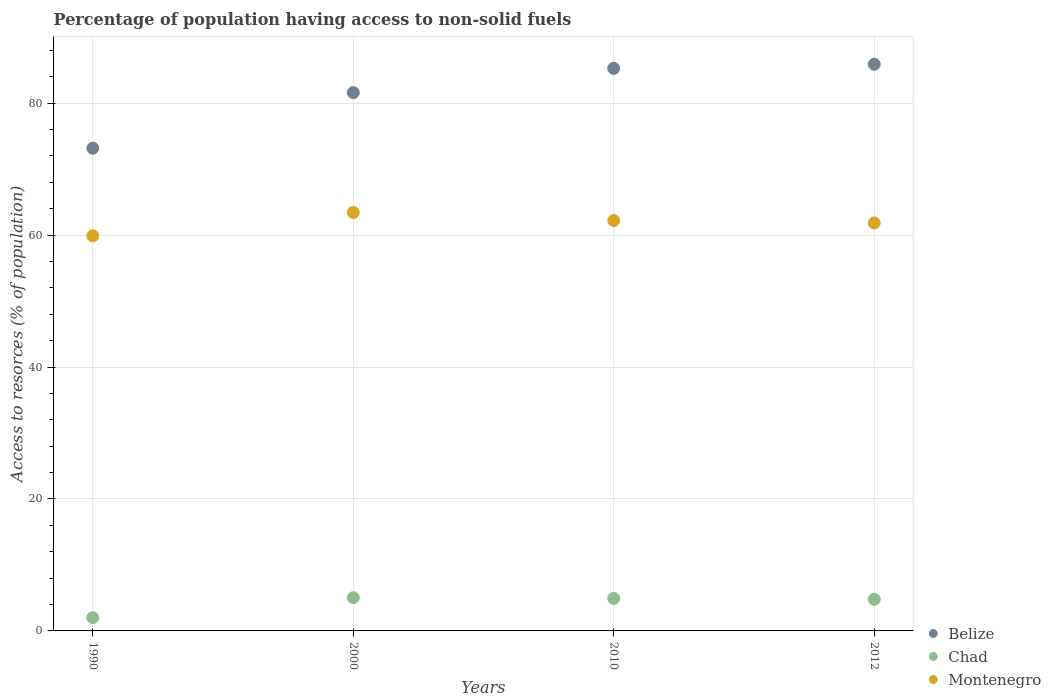How many different coloured dotlines are there?
Your response must be concise. 3. Is the number of dotlines equal to the number of legend labels?
Keep it short and to the point. Yes. What is the percentage of population having access to non-solid fuels in Chad in 2010?
Make the answer very short. 4.92. Across all years, what is the maximum percentage of population having access to non-solid fuels in Belize?
Provide a short and direct response. 85.89. Across all years, what is the minimum percentage of population having access to non-solid fuels in Chad?
Your response must be concise. 2.01. In which year was the percentage of population having access to non-solid fuels in Montenegro maximum?
Your answer should be compact. 2000. What is the total percentage of population having access to non-solid fuels in Chad in the graph?
Provide a short and direct response. 16.76. What is the difference between the percentage of population having access to non-solid fuels in Belize in 2000 and that in 2010?
Offer a very short reply. -3.67. What is the difference between the percentage of population having access to non-solid fuels in Belize in 2010 and the percentage of population having access to non-solid fuels in Montenegro in 2012?
Ensure brevity in your answer.  23.43. What is the average percentage of population having access to non-solid fuels in Montenegro per year?
Keep it short and to the point. 61.84. In the year 1990, what is the difference between the percentage of population having access to non-solid fuels in Chad and percentage of population having access to non-solid fuels in Montenegro?
Give a very brief answer. -57.87. What is the ratio of the percentage of population having access to non-solid fuels in Belize in 1990 to that in 2012?
Give a very brief answer. 0.85. Is the percentage of population having access to non-solid fuels in Belize in 2000 less than that in 2012?
Offer a very short reply. Yes. Is the difference between the percentage of population having access to non-solid fuels in Chad in 2000 and 2012 greater than the difference between the percentage of population having access to non-solid fuels in Montenegro in 2000 and 2012?
Keep it short and to the point. No. What is the difference between the highest and the second highest percentage of population having access to non-solid fuels in Chad?
Your answer should be compact. 0.11. What is the difference between the highest and the lowest percentage of population having access to non-solid fuels in Belize?
Keep it short and to the point. 12.73. In how many years, is the percentage of population having access to non-solid fuels in Chad greater than the average percentage of population having access to non-solid fuels in Chad taken over all years?
Your response must be concise. 3. Is the sum of the percentage of population having access to non-solid fuels in Montenegro in 1990 and 2000 greater than the maximum percentage of population having access to non-solid fuels in Chad across all years?
Your answer should be compact. Yes. Is the percentage of population having access to non-solid fuels in Montenegro strictly greater than the percentage of population having access to non-solid fuels in Belize over the years?
Provide a short and direct response. No. Is the percentage of population having access to non-solid fuels in Belize strictly less than the percentage of population having access to non-solid fuels in Montenegro over the years?
Offer a very short reply. No. What is the difference between two consecutive major ticks on the Y-axis?
Your response must be concise. 20. Does the graph contain grids?
Provide a short and direct response. Yes. Where does the legend appear in the graph?
Provide a succinct answer. Bottom right. How many legend labels are there?
Your answer should be very brief. 3. How are the legend labels stacked?
Offer a very short reply. Vertical. What is the title of the graph?
Give a very brief answer. Percentage of population having access to non-solid fuels. What is the label or title of the Y-axis?
Offer a very short reply. Access to resorces (% of population). What is the Access to resorces (% of population) of Belize in 1990?
Your answer should be very brief. 73.17. What is the Access to resorces (% of population) of Chad in 1990?
Your answer should be compact. 2.01. What is the Access to resorces (% of population) in Montenegro in 1990?
Provide a succinct answer. 59.88. What is the Access to resorces (% of population) of Belize in 2000?
Your answer should be compact. 81.6. What is the Access to resorces (% of population) in Chad in 2000?
Your answer should be very brief. 5.04. What is the Access to resorces (% of population) in Montenegro in 2000?
Keep it short and to the point. 63.42. What is the Access to resorces (% of population) of Belize in 2010?
Your answer should be very brief. 85.27. What is the Access to resorces (% of population) in Chad in 2010?
Make the answer very short. 4.92. What is the Access to resorces (% of population) in Montenegro in 2010?
Offer a very short reply. 62.2. What is the Access to resorces (% of population) of Belize in 2012?
Your answer should be compact. 85.89. What is the Access to resorces (% of population) of Chad in 2012?
Your response must be concise. 4.79. What is the Access to resorces (% of population) of Montenegro in 2012?
Your answer should be very brief. 61.85. Across all years, what is the maximum Access to resorces (% of population) in Belize?
Give a very brief answer. 85.89. Across all years, what is the maximum Access to resorces (% of population) in Chad?
Provide a short and direct response. 5.04. Across all years, what is the maximum Access to resorces (% of population) of Montenegro?
Provide a short and direct response. 63.42. Across all years, what is the minimum Access to resorces (% of population) in Belize?
Give a very brief answer. 73.17. Across all years, what is the minimum Access to resorces (% of population) of Chad?
Your answer should be very brief. 2.01. Across all years, what is the minimum Access to resorces (% of population) of Montenegro?
Give a very brief answer. 59.88. What is the total Access to resorces (% of population) in Belize in the graph?
Ensure brevity in your answer.  325.93. What is the total Access to resorces (% of population) of Chad in the graph?
Keep it short and to the point. 16.76. What is the total Access to resorces (% of population) of Montenegro in the graph?
Your answer should be compact. 247.34. What is the difference between the Access to resorces (% of population) of Belize in 1990 and that in 2000?
Provide a succinct answer. -8.43. What is the difference between the Access to resorces (% of population) of Chad in 1990 and that in 2000?
Your response must be concise. -3.03. What is the difference between the Access to resorces (% of population) in Montenegro in 1990 and that in 2000?
Ensure brevity in your answer.  -3.54. What is the difference between the Access to resorces (% of population) of Belize in 1990 and that in 2010?
Offer a very short reply. -12.1. What is the difference between the Access to resorces (% of population) of Chad in 1990 and that in 2010?
Provide a short and direct response. -2.92. What is the difference between the Access to resorces (% of population) of Montenegro in 1990 and that in 2010?
Ensure brevity in your answer.  -2.32. What is the difference between the Access to resorces (% of population) of Belize in 1990 and that in 2012?
Keep it short and to the point. -12.73. What is the difference between the Access to resorces (% of population) in Chad in 1990 and that in 2012?
Make the answer very short. -2.78. What is the difference between the Access to resorces (% of population) in Montenegro in 1990 and that in 2012?
Offer a very short reply. -1.97. What is the difference between the Access to resorces (% of population) in Belize in 2000 and that in 2010?
Your answer should be compact. -3.67. What is the difference between the Access to resorces (% of population) in Chad in 2000 and that in 2010?
Keep it short and to the point. 0.11. What is the difference between the Access to resorces (% of population) of Montenegro in 2000 and that in 2010?
Your response must be concise. 1.22. What is the difference between the Access to resorces (% of population) in Belize in 2000 and that in 2012?
Give a very brief answer. -4.3. What is the difference between the Access to resorces (% of population) of Chad in 2000 and that in 2012?
Your answer should be compact. 0.24. What is the difference between the Access to resorces (% of population) of Montenegro in 2000 and that in 2012?
Offer a very short reply. 1.58. What is the difference between the Access to resorces (% of population) of Belize in 2010 and that in 2012?
Keep it short and to the point. -0.62. What is the difference between the Access to resorces (% of population) of Chad in 2010 and that in 2012?
Keep it short and to the point. 0.13. What is the difference between the Access to resorces (% of population) of Montenegro in 2010 and that in 2012?
Keep it short and to the point. 0.35. What is the difference between the Access to resorces (% of population) in Belize in 1990 and the Access to resorces (% of population) in Chad in 2000?
Your answer should be compact. 68.13. What is the difference between the Access to resorces (% of population) in Belize in 1990 and the Access to resorces (% of population) in Montenegro in 2000?
Offer a terse response. 9.74. What is the difference between the Access to resorces (% of population) of Chad in 1990 and the Access to resorces (% of population) of Montenegro in 2000?
Give a very brief answer. -61.41. What is the difference between the Access to resorces (% of population) in Belize in 1990 and the Access to resorces (% of population) in Chad in 2010?
Offer a very short reply. 68.24. What is the difference between the Access to resorces (% of population) in Belize in 1990 and the Access to resorces (% of population) in Montenegro in 2010?
Keep it short and to the point. 10.97. What is the difference between the Access to resorces (% of population) of Chad in 1990 and the Access to resorces (% of population) of Montenegro in 2010?
Your response must be concise. -60.19. What is the difference between the Access to resorces (% of population) in Belize in 1990 and the Access to resorces (% of population) in Chad in 2012?
Provide a succinct answer. 68.38. What is the difference between the Access to resorces (% of population) in Belize in 1990 and the Access to resorces (% of population) in Montenegro in 2012?
Provide a short and direct response. 11.32. What is the difference between the Access to resorces (% of population) of Chad in 1990 and the Access to resorces (% of population) of Montenegro in 2012?
Offer a very short reply. -59.84. What is the difference between the Access to resorces (% of population) in Belize in 2000 and the Access to resorces (% of population) in Chad in 2010?
Your answer should be compact. 76.67. What is the difference between the Access to resorces (% of population) in Belize in 2000 and the Access to resorces (% of population) in Montenegro in 2010?
Give a very brief answer. 19.4. What is the difference between the Access to resorces (% of population) in Chad in 2000 and the Access to resorces (% of population) in Montenegro in 2010?
Ensure brevity in your answer.  -57.16. What is the difference between the Access to resorces (% of population) of Belize in 2000 and the Access to resorces (% of population) of Chad in 2012?
Keep it short and to the point. 76.8. What is the difference between the Access to resorces (% of population) in Belize in 2000 and the Access to resorces (% of population) in Montenegro in 2012?
Your answer should be very brief. 19.75. What is the difference between the Access to resorces (% of population) in Chad in 2000 and the Access to resorces (% of population) in Montenegro in 2012?
Offer a terse response. -56.81. What is the difference between the Access to resorces (% of population) in Belize in 2010 and the Access to resorces (% of population) in Chad in 2012?
Make the answer very short. 80.48. What is the difference between the Access to resorces (% of population) in Belize in 2010 and the Access to resorces (% of population) in Montenegro in 2012?
Make the answer very short. 23.43. What is the difference between the Access to resorces (% of population) in Chad in 2010 and the Access to resorces (% of population) in Montenegro in 2012?
Offer a terse response. -56.92. What is the average Access to resorces (% of population) of Belize per year?
Offer a terse response. 81.48. What is the average Access to resorces (% of population) of Chad per year?
Offer a terse response. 4.19. What is the average Access to resorces (% of population) of Montenegro per year?
Keep it short and to the point. 61.84. In the year 1990, what is the difference between the Access to resorces (% of population) in Belize and Access to resorces (% of population) in Chad?
Keep it short and to the point. 71.16. In the year 1990, what is the difference between the Access to resorces (% of population) of Belize and Access to resorces (% of population) of Montenegro?
Provide a short and direct response. 13.29. In the year 1990, what is the difference between the Access to resorces (% of population) of Chad and Access to resorces (% of population) of Montenegro?
Offer a very short reply. -57.87. In the year 2000, what is the difference between the Access to resorces (% of population) in Belize and Access to resorces (% of population) in Chad?
Provide a short and direct response. 76.56. In the year 2000, what is the difference between the Access to resorces (% of population) of Belize and Access to resorces (% of population) of Montenegro?
Your response must be concise. 18.17. In the year 2000, what is the difference between the Access to resorces (% of population) of Chad and Access to resorces (% of population) of Montenegro?
Provide a succinct answer. -58.39. In the year 2010, what is the difference between the Access to resorces (% of population) in Belize and Access to resorces (% of population) in Chad?
Offer a terse response. 80.35. In the year 2010, what is the difference between the Access to resorces (% of population) of Belize and Access to resorces (% of population) of Montenegro?
Your response must be concise. 23.07. In the year 2010, what is the difference between the Access to resorces (% of population) of Chad and Access to resorces (% of population) of Montenegro?
Provide a succinct answer. -57.27. In the year 2012, what is the difference between the Access to resorces (% of population) of Belize and Access to resorces (% of population) of Chad?
Provide a succinct answer. 81.1. In the year 2012, what is the difference between the Access to resorces (% of population) in Belize and Access to resorces (% of population) in Montenegro?
Offer a terse response. 24.05. In the year 2012, what is the difference between the Access to resorces (% of population) of Chad and Access to resorces (% of population) of Montenegro?
Provide a short and direct response. -57.05. What is the ratio of the Access to resorces (% of population) of Belize in 1990 to that in 2000?
Your response must be concise. 0.9. What is the ratio of the Access to resorces (% of population) of Chad in 1990 to that in 2000?
Your answer should be very brief. 0.4. What is the ratio of the Access to resorces (% of population) of Montenegro in 1990 to that in 2000?
Give a very brief answer. 0.94. What is the ratio of the Access to resorces (% of population) of Belize in 1990 to that in 2010?
Make the answer very short. 0.86. What is the ratio of the Access to resorces (% of population) in Chad in 1990 to that in 2010?
Make the answer very short. 0.41. What is the ratio of the Access to resorces (% of population) of Montenegro in 1990 to that in 2010?
Provide a short and direct response. 0.96. What is the ratio of the Access to resorces (% of population) of Belize in 1990 to that in 2012?
Your answer should be very brief. 0.85. What is the ratio of the Access to resorces (% of population) in Chad in 1990 to that in 2012?
Give a very brief answer. 0.42. What is the ratio of the Access to resorces (% of population) in Montenegro in 1990 to that in 2012?
Provide a succinct answer. 0.97. What is the ratio of the Access to resorces (% of population) in Belize in 2000 to that in 2010?
Give a very brief answer. 0.96. What is the ratio of the Access to resorces (% of population) of Chad in 2000 to that in 2010?
Your answer should be compact. 1.02. What is the ratio of the Access to resorces (% of population) in Montenegro in 2000 to that in 2010?
Give a very brief answer. 1.02. What is the ratio of the Access to resorces (% of population) in Belize in 2000 to that in 2012?
Your response must be concise. 0.95. What is the ratio of the Access to resorces (% of population) of Chad in 2000 to that in 2012?
Offer a terse response. 1.05. What is the ratio of the Access to resorces (% of population) of Montenegro in 2000 to that in 2012?
Provide a succinct answer. 1.03. What is the ratio of the Access to resorces (% of population) of Chad in 2010 to that in 2012?
Provide a succinct answer. 1.03. What is the ratio of the Access to resorces (% of population) of Montenegro in 2010 to that in 2012?
Give a very brief answer. 1.01. What is the difference between the highest and the second highest Access to resorces (% of population) of Belize?
Make the answer very short. 0.62. What is the difference between the highest and the second highest Access to resorces (% of population) in Chad?
Provide a short and direct response. 0.11. What is the difference between the highest and the second highest Access to resorces (% of population) in Montenegro?
Provide a short and direct response. 1.22. What is the difference between the highest and the lowest Access to resorces (% of population) in Belize?
Your response must be concise. 12.73. What is the difference between the highest and the lowest Access to resorces (% of population) of Chad?
Offer a very short reply. 3.03. What is the difference between the highest and the lowest Access to resorces (% of population) in Montenegro?
Keep it short and to the point. 3.54. 